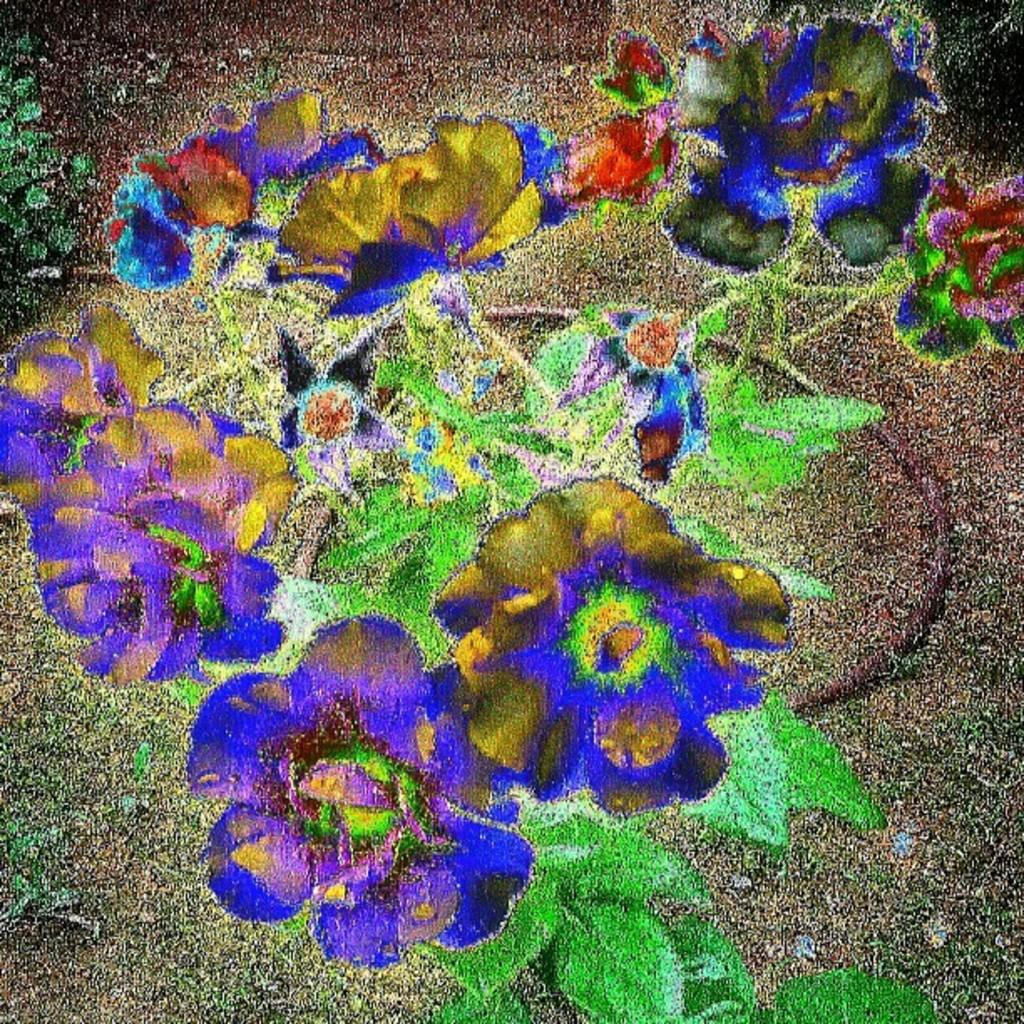What type of plants can be seen in the image? There are flower plants in the image. How many toes can be seen on the flower plants in the image? There are no toes present on the flower plants in the image, as they are plants and not living beings with toes. 